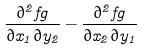<formula> <loc_0><loc_0><loc_500><loc_500>\frac { \partial ^ { 2 } f g } { \partial x _ { 1 } \partial y _ { 2 } } - \frac { \partial ^ { 2 } f g } { \partial x _ { 2 } \partial y _ { 1 } }</formula> 